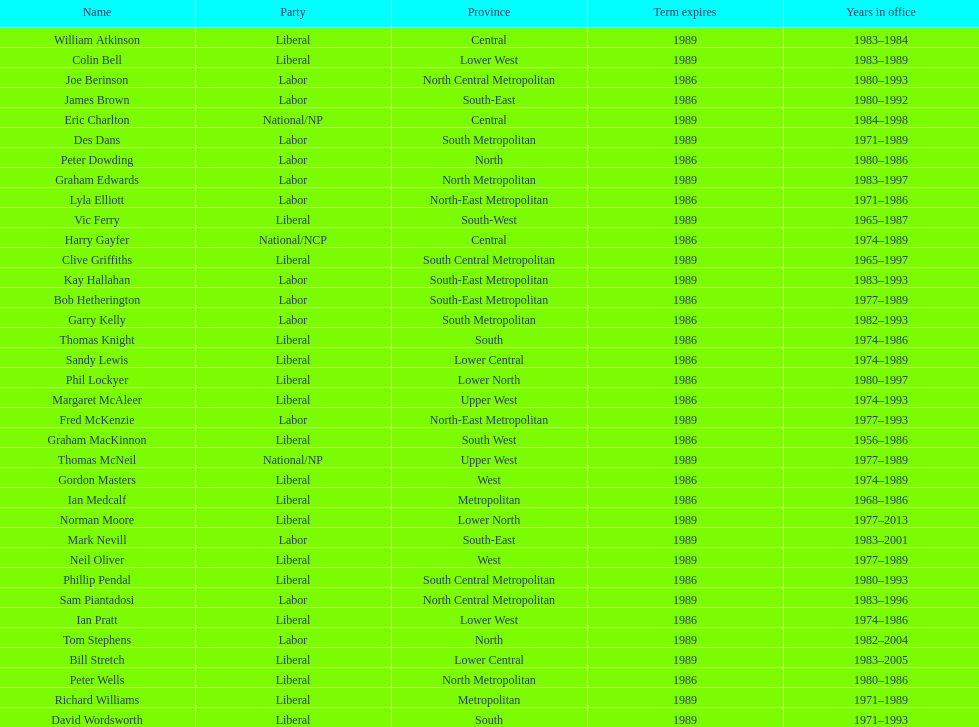How many people were part of the lower west province's party? 2. 